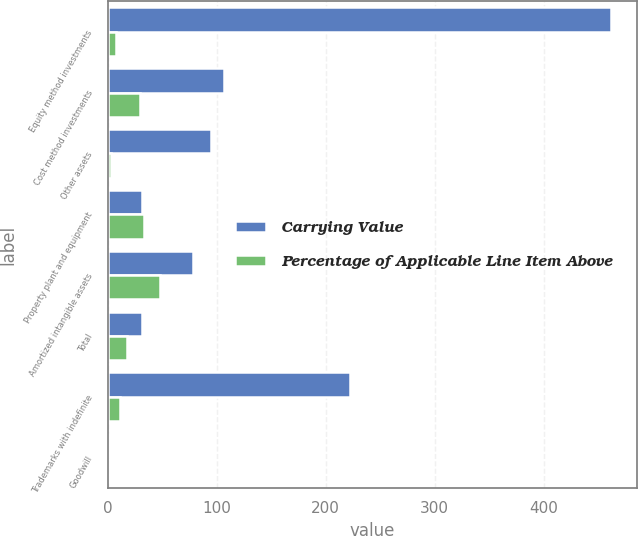<chart> <loc_0><loc_0><loc_500><loc_500><stacked_bar_chart><ecel><fcel>Equity method investments<fcel>Cost method investments<fcel>Other assets<fcel>Property plant and equipment<fcel>Amortized intangible assets<fcel>Total<fcel>Trademarks with indefinite<fcel>Goodwill<nl><fcel>Carrying Value<fcel>462<fcel>107<fcel>95<fcel>31.5<fcel>78<fcel>31.5<fcel>222<fcel>0<nl><fcel>Percentage of Applicable Line Item Above<fcel>8<fcel>30<fcel>3<fcel>33<fcel>48<fcel>18<fcel>11<fcel>0<nl></chart> 